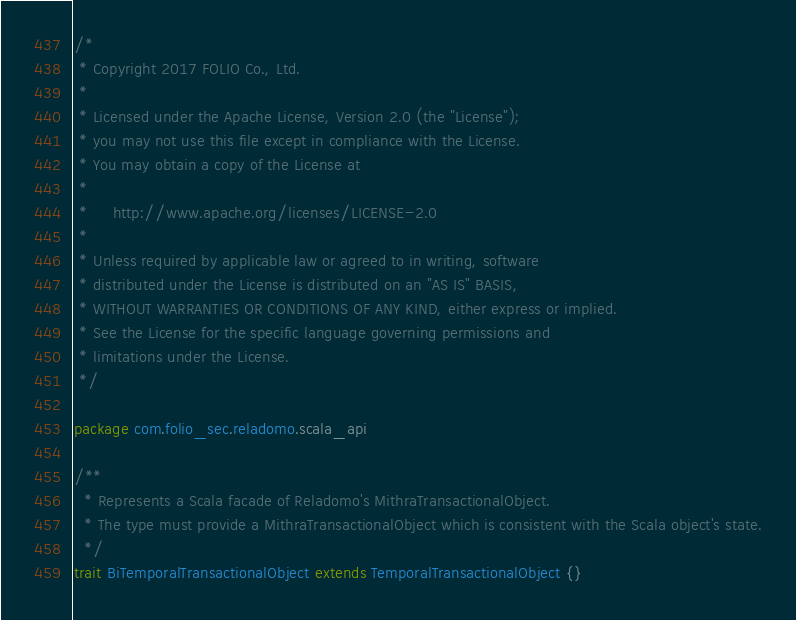Convert code to text. <code><loc_0><loc_0><loc_500><loc_500><_Scala_>/*
 * Copyright 2017 FOLIO Co., Ltd.
 *
 * Licensed under the Apache License, Version 2.0 (the "License");
 * you may not use this file except in compliance with the License.
 * You may obtain a copy of the License at
 *
 *     http://www.apache.org/licenses/LICENSE-2.0
 *
 * Unless required by applicable law or agreed to in writing, software
 * distributed under the License is distributed on an "AS IS" BASIS,
 * WITHOUT WARRANTIES OR CONDITIONS OF ANY KIND, either express or implied.
 * See the License for the specific language governing permissions and
 * limitations under the License.
 */

package com.folio_sec.reladomo.scala_api

/**
  * Represents a Scala facade of Reladomo's MithraTransactionalObject.
  * The type must provide a MithraTransactionalObject which is consistent with the Scala object's state.
  */
trait BiTemporalTransactionalObject extends TemporalTransactionalObject {}
</code> 